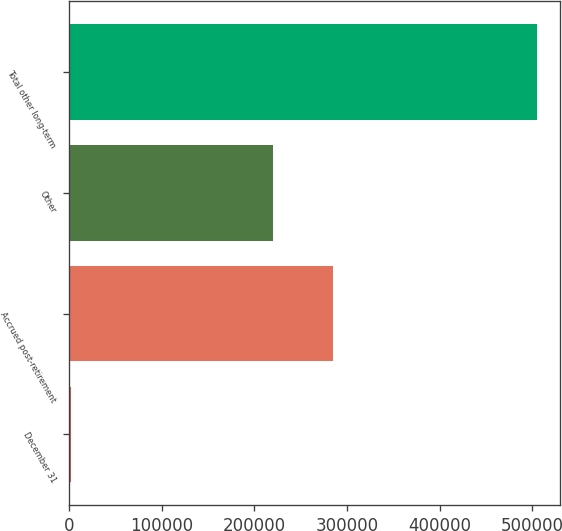<chart> <loc_0><loc_0><loc_500><loc_500><bar_chart><fcel>December 31<fcel>Accrued post-retirement<fcel>Other<fcel>Total other long-term<nl><fcel>2008<fcel>285001<fcel>219962<fcel>504963<nl></chart> 